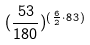Convert formula to latex. <formula><loc_0><loc_0><loc_500><loc_500>( \frac { 5 3 } { 1 8 0 } ) ^ { ( \frac { 6 } { 2 } \cdot 8 3 ) }</formula> 